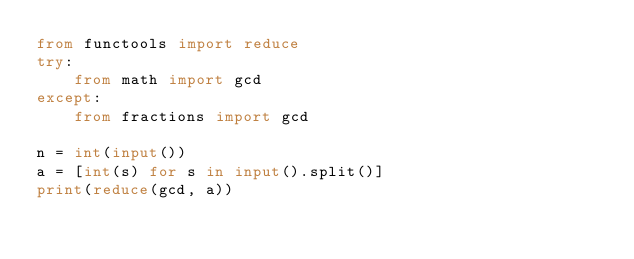Convert code to text. <code><loc_0><loc_0><loc_500><loc_500><_Python_>from functools import reduce
try:
    from math import gcd
except:
    from fractions import gcd

n = int(input())
a = [int(s) for s in input().split()]
print(reduce(gcd, a))
</code> 